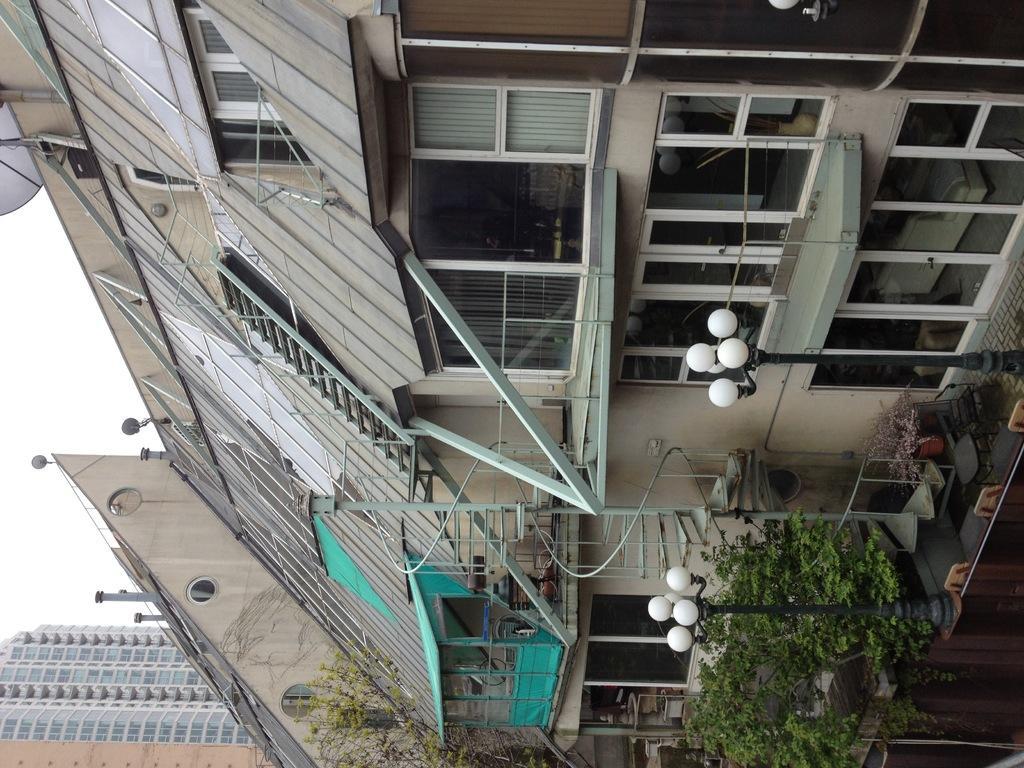Describe this image in one or two sentences. In this image there are some houses, poles, lights, trees and we could see some windows and some pillars, railing. On the right side of the image there is sky and some poles and antenna is there on the building. 